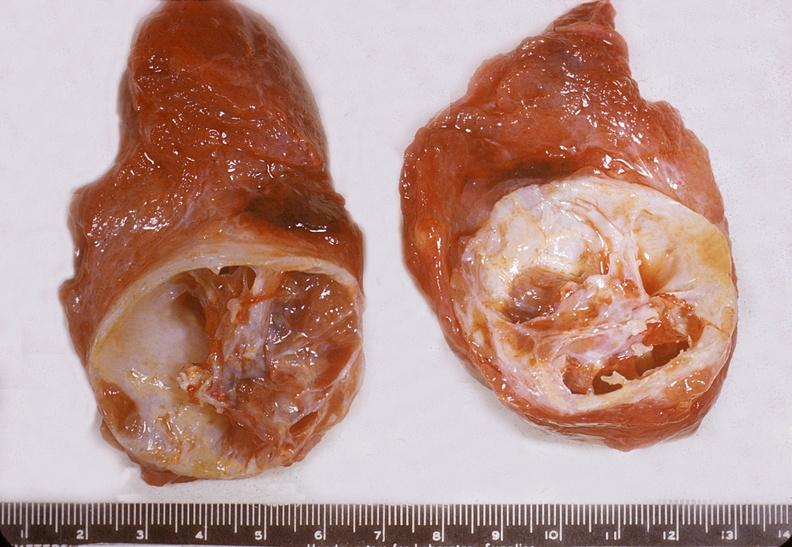what is present?
Answer the question using a single word or phrase. Endocrine 